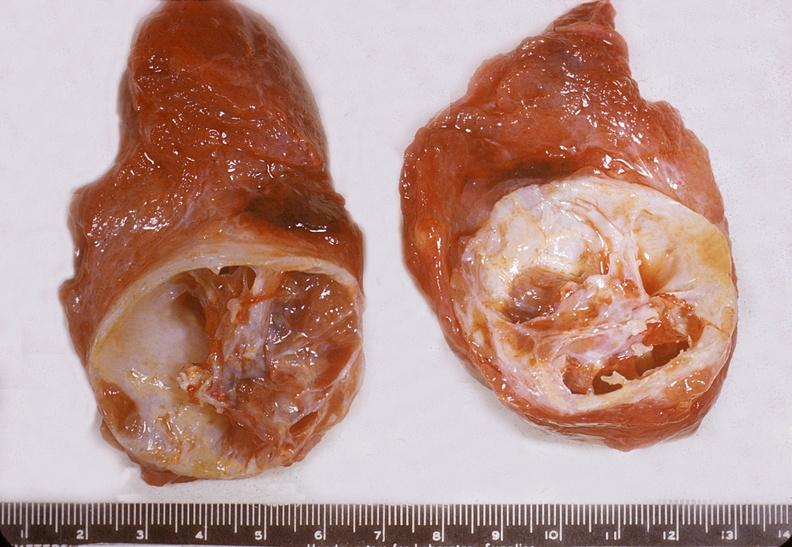what is present?
Answer the question using a single word or phrase. Endocrine 